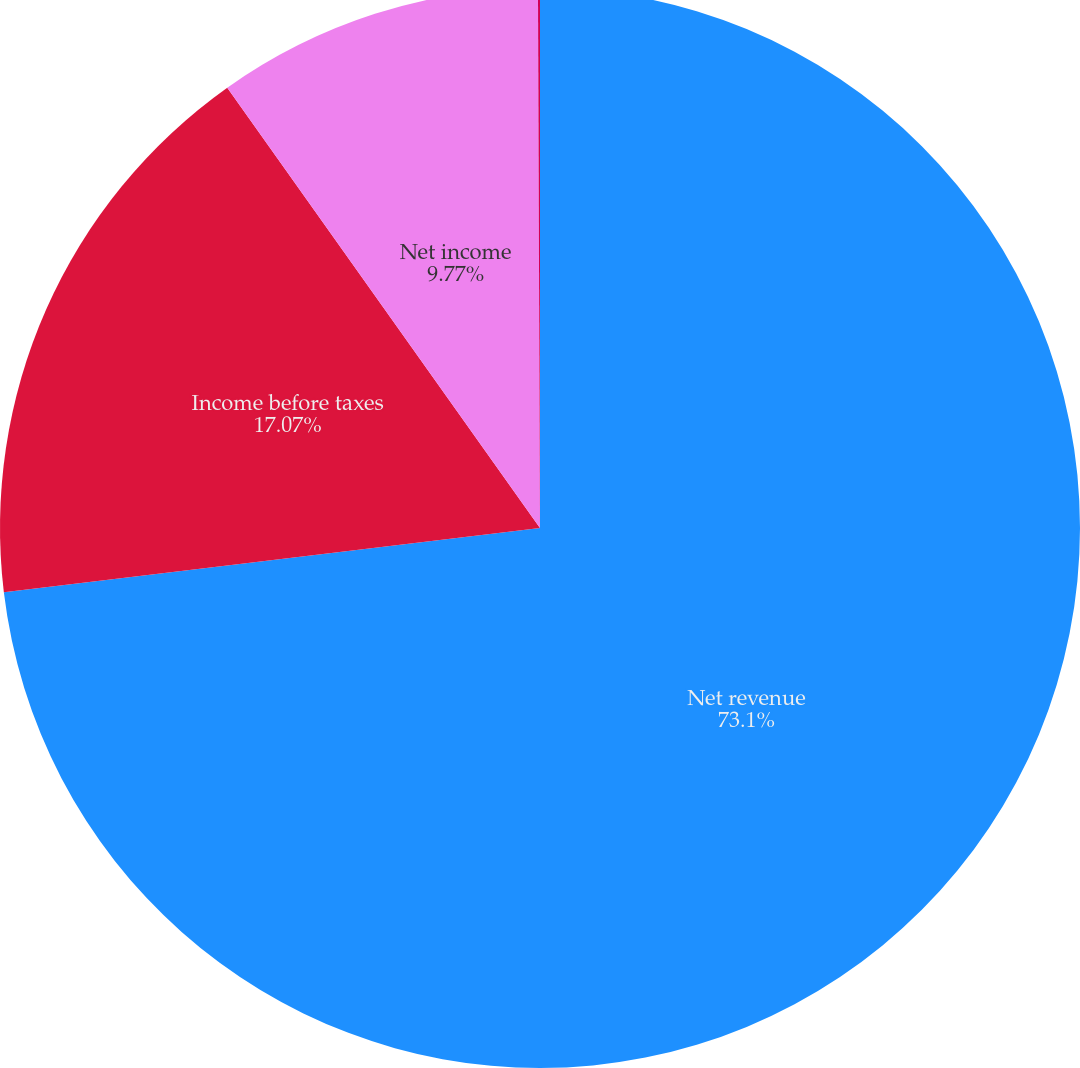Convert chart to OTSL. <chart><loc_0><loc_0><loc_500><loc_500><pie_chart><fcel>Net revenue<fcel>Income before taxes<fcel>Net income<fcel>Basic<nl><fcel>73.1%<fcel>17.07%<fcel>9.77%<fcel>0.06%<nl></chart> 